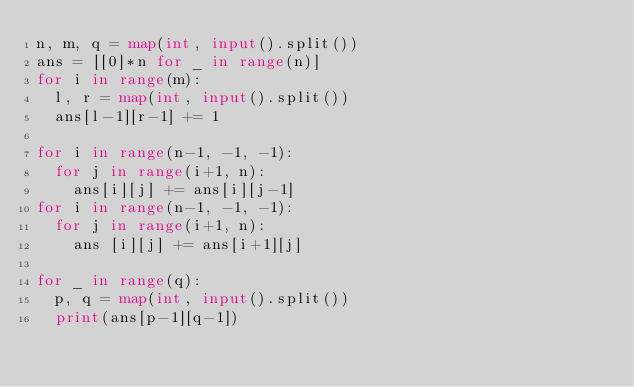<code> <loc_0><loc_0><loc_500><loc_500><_Python_>n, m, q = map(int, input().split())
ans = [[0]*n for _ in range(n)]
for i in range(m):
  l, r = map(int, input().split())
  ans[l-1][r-1] += 1

for i in range(n-1, -1, -1):
  for j in range(i+1, n):
    ans[i][j] += ans[i][j-1]
for i in range(n-1, -1, -1):
  for j in range(i+1, n):
    ans [i][j] += ans[i+1][j]

for _ in range(q):
  p, q = map(int, input().split())
  print(ans[p-1][q-1])</code> 